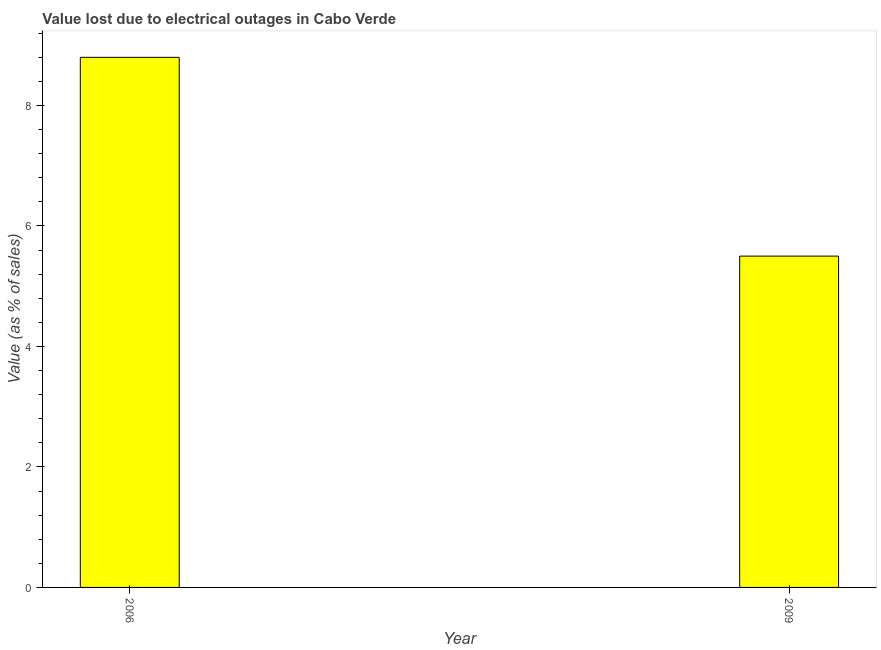Does the graph contain any zero values?
Your answer should be compact. No. Does the graph contain grids?
Your answer should be compact. No. What is the title of the graph?
Your answer should be very brief. Value lost due to electrical outages in Cabo Verde. What is the label or title of the Y-axis?
Your answer should be very brief. Value (as % of sales). What is the value lost due to electrical outages in 2006?
Provide a short and direct response. 8.8. Across all years, what is the maximum value lost due to electrical outages?
Keep it short and to the point. 8.8. In which year was the value lost due to electrical outages maximum?
Your response must be concise. 2006. What is the sum of the value lost due to electrical outages?
Offer a terse response. 14.3. What is the average value lost due to electrical outages per year?
Provide a short and direct response. 7.15. What is the median value lost due to electrical outages?
Provide a short and direct response. 7.15. Do a majority of the years between 2009 and 2006 (inclusive) have value lost due to electrical outages greater than 1.2 %?
Your answer should be compact. No. What is the ratio of the value lost due to electrical outages in 2006 to that in 2009?
Provide a short and direct response. 1.6. In how many years, is the value lost due to electrical outages greater than the average value lost due to electrical outages taken over all years?
Offer a terse response. 1. Are all the bars in the graph horizontal?
Offer a very short reply. No. How many years are there in the graph?
Your answer should be very brief. 2. What is the difference between two consecutive major ticks on the Y-axis?
Make the answer very short. 2. Are the values on the major ticks of Y-axis written in scientific E-notation?
Make the answer very short. No. What is the Value (as % of sales) of 2006?
Keep it short and to the point. 8.8. 